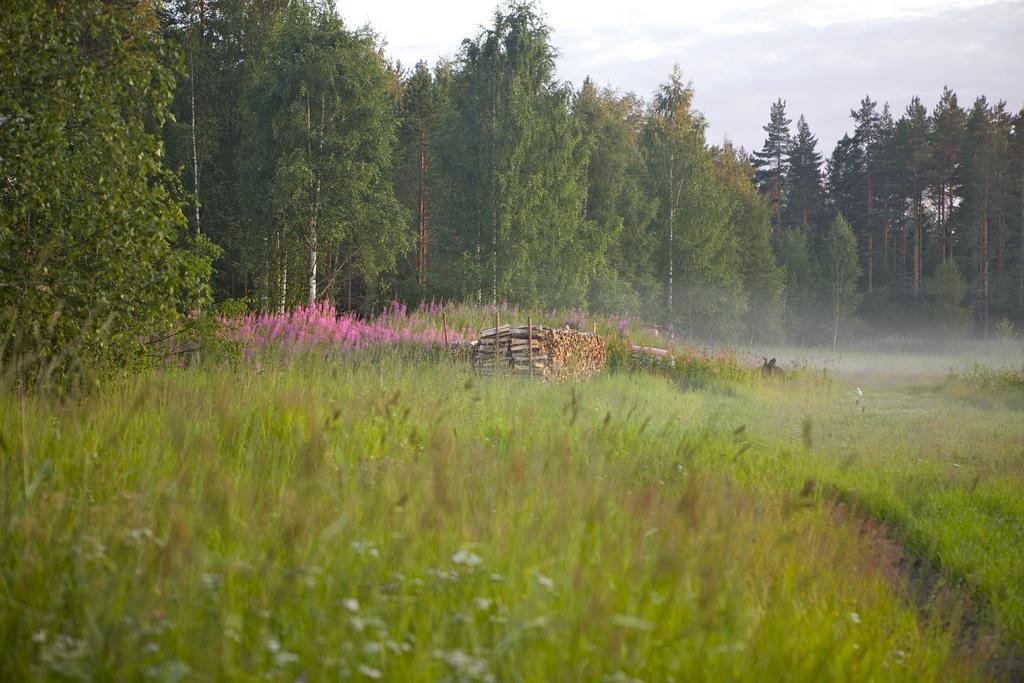Could you give a brief overview of what you see in this image? This image is taken outdoors. At the bottom of the image there is a ground with grass and a few plants on it. At the top of the image there is the sky with clouds. In the background there are many trees and plants with stems, green leaves and branches on the ground. There are few flowers. In the middle of the image there are a few wooden sticks. 